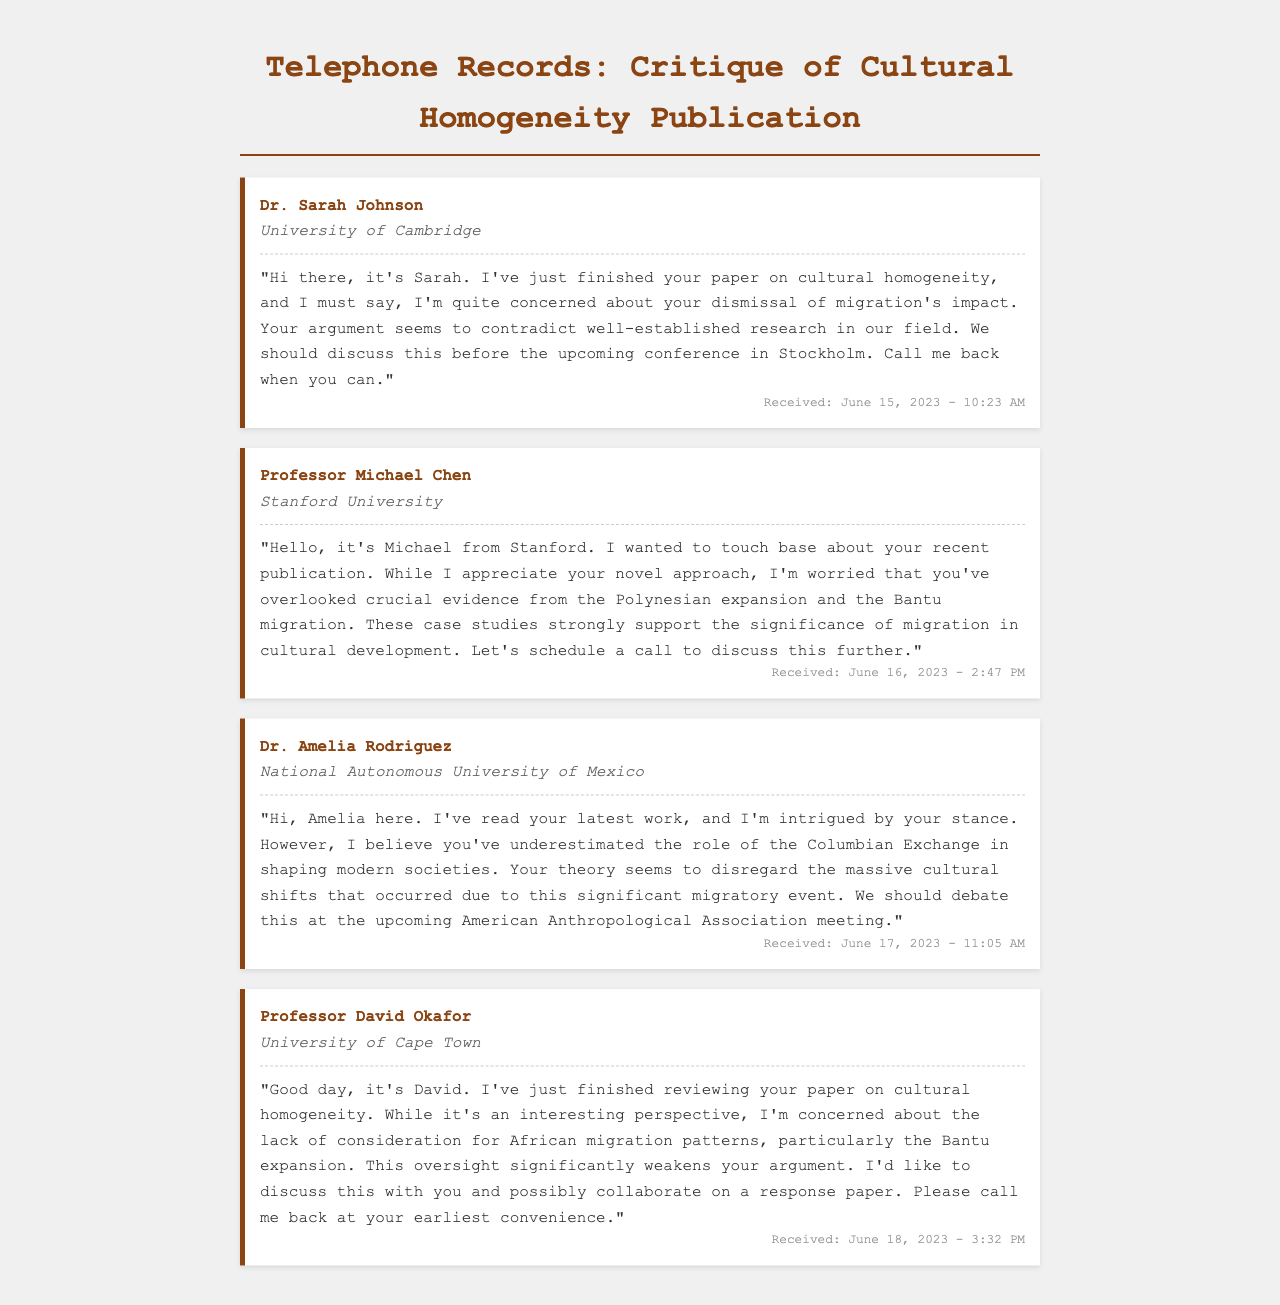What is the name of the first caller? The name of the first caller is provided in the document as "Dr. Sarah Johnson."
Answer: Dr. Sarah Johnson What institution does Professor Michael Chen belong to? The document specifies that Professor Michael Chen is from "Stanford University."
Answer: Stanford University What date was Dr. Amelia Rodriguez's message received? The document states that Dr. Amelia Rodriguez's message was received on "June 17, 2023."
Answer: June 17, 2023 What is the specific concern raised by Professor David Okafor? Professor David Okafor's concern, as stated in the document, is about the "lack of consideration for African migration patterns."
Answer: lack of consideration for African migration patterns Which migratory event does Dr. Amelia Rodriguez mention as significant? Dr. Amelia Rodriguez mentions the "Columbian Exchange" as a significant migratory event in her message.
Answer: Columbian Exchange How many colleagues left messages regarding the publication? The document lists four colleagues who left messages regarding the publication, detailing their critiques.
Answer: four What is the timestamp of Professor Michael Chen's voicemail? The voicemail from Professor Michael Chen indicates it was received at "June 16, 2023 - 2:47 PM."
Answer: June 16, 2023 - 2:47 PM Which conference is mentioned for the discussion? The document mentions discussing the paper at the "upcoming conference in Stockholm."
Answer: upcoming conference in Stockholm 